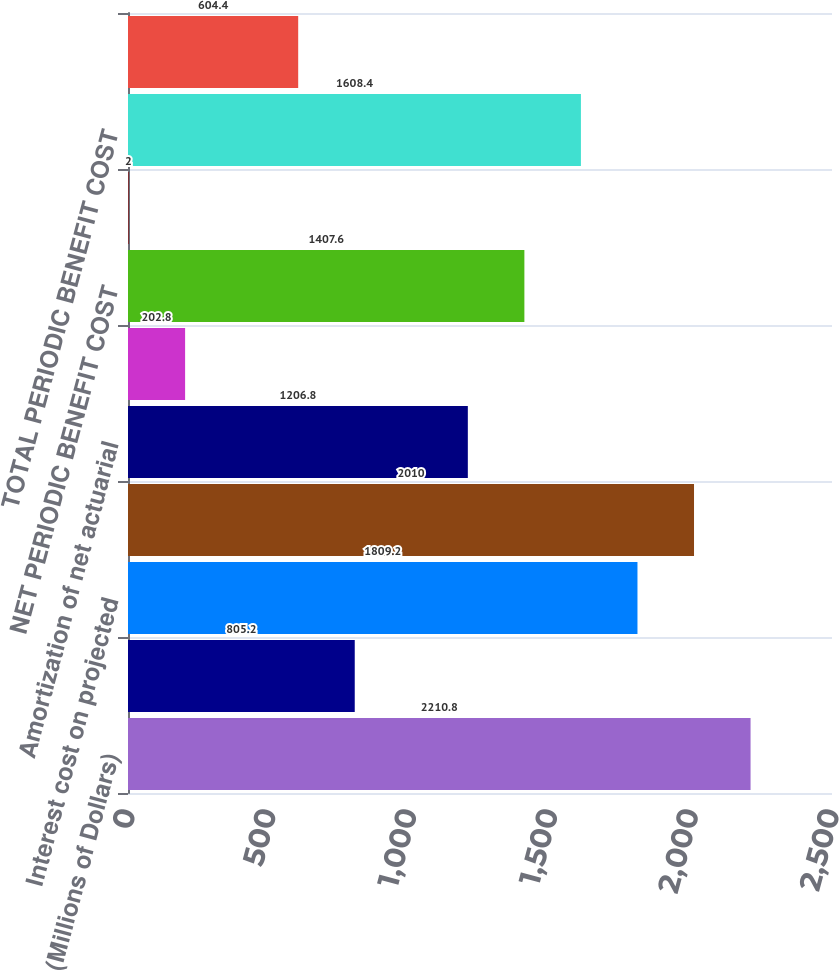Convert chart. <chart><loc_0><loc_0><loc_500><loc_500><bar_chart><fcel>(Millions of Dollars)<fcel>Service cost - including<fcel>Interest cost on projected<fcel>Expected return on plan assets<fcel>Amortization of net actuarial<fcel>Amortization of prior service<fcel>NET PERIODIC BENEFIT COST<fcel>Amortization of regulatory<fcel>TOTAL PERIODIC BENEFIT COST<fcel>Cost capitalized<nl><fcel>2210.8<fcel>805.2<fcel>1809.2<fcel>2010<fcel>1206.8<fcel>202.8<fcel>1407.6<fcel>2<fcel>1608.4<fcel>604.4<nl></chart> 